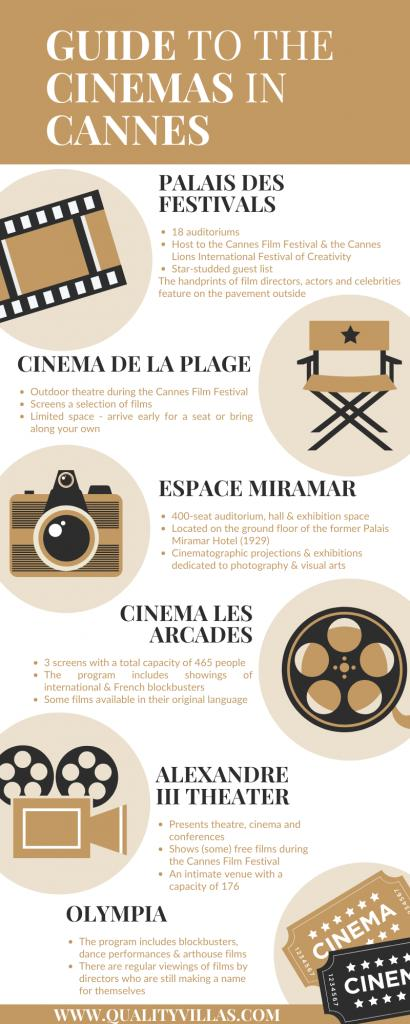Specify some key components in this picture. Espace Miramar features a 400-seat auditorium and a hall and exhibition space for various events and gatherings. There are six cinema centers mentioned in this guide. Cinema de la Plage is represented by a seat as it is a beach cinema that offers a unique experience of watching movies under the stars. The Cannes Film Festival and the Cannes Lions International Festival of Creativity were both hosted at the Palais des Festivals in Cannes. Olympia Theatre regularly showcases the works of up-and-coming filmmakers who are establishing their careers. 